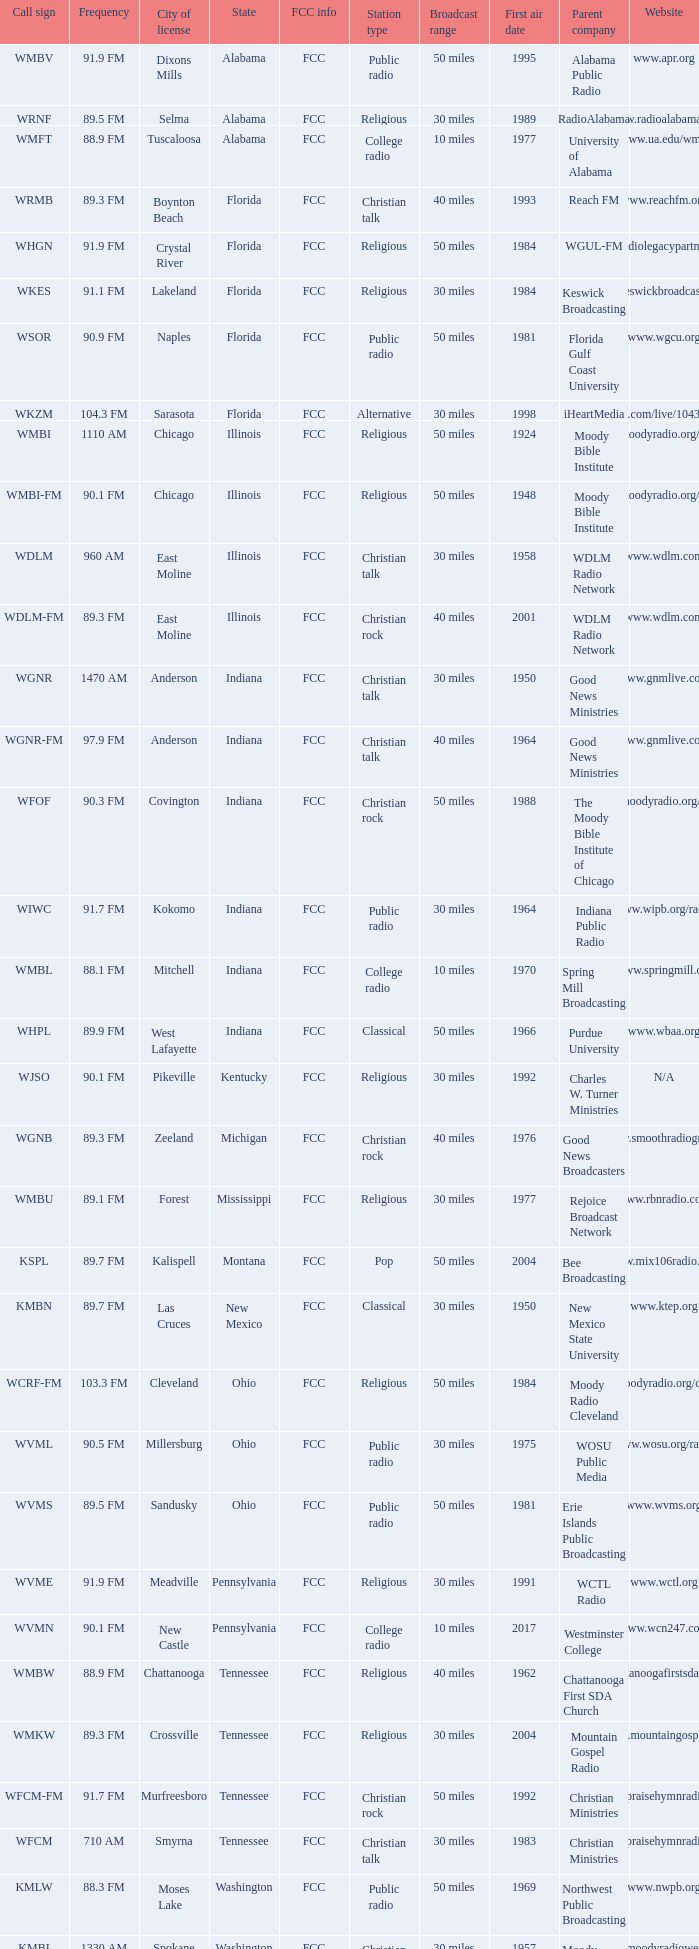Where is the 103.3 fm radio station authorized to operate? Cleveland. 